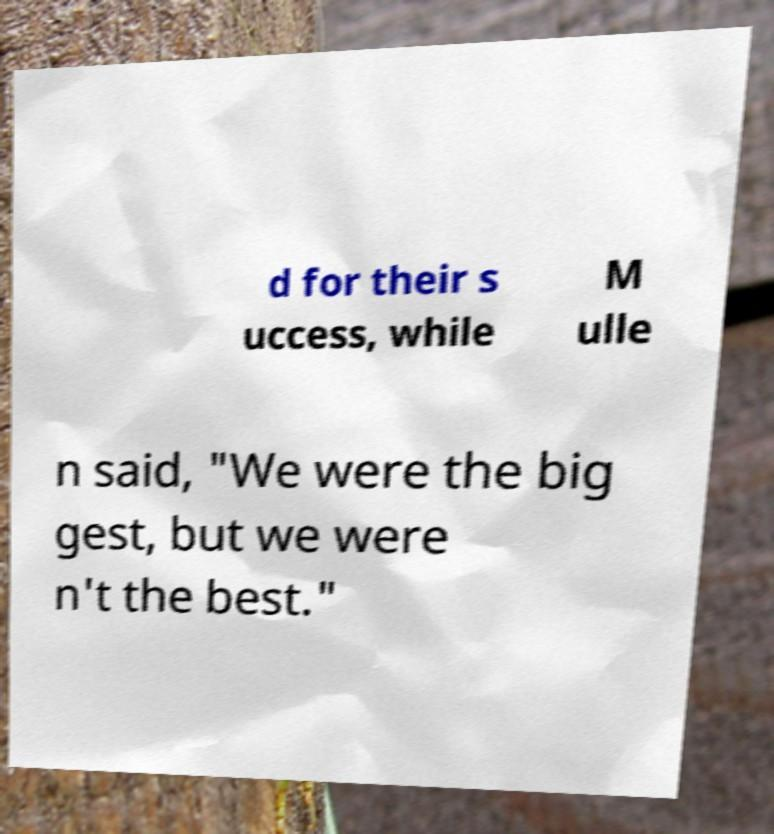Please identify and transcribe the text found in this image. d for their s uccess, while M ulle n said, "We were the big gest, but we were n't the best." 